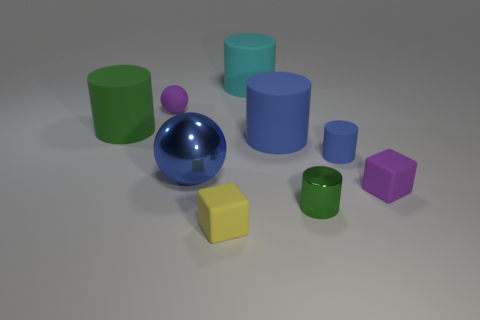There is another object that is the same color as the tiny metallic object; what size is it?
Your answer should be very brief. Large. There is a small cylinder that is the same color as the big ball; what is it made of?
Provide a short and direct response. Rubber. Is the shape of the small purple thing that is to the right of the cyan cylinder the same as the big matte thing that is to the left of the blue sphere?
Provide a succinct answer. No. Are there any other things that are the same size as the yellow matte object?
Your answer should be very brief. Yes. What number of spheres are red shiny objects or yellow matte things?
Ensure brevity in your answer.  0. Does the tiny yellow cube have the same material as the tiny blue thing?
Your answer should be very brief. Yes. How many other things are there of the same color as the matte ball?
Offer a very short reply. 1. There is a large object on the left side of the blue metallic sphere; what is its shape?
Your response must be concise. Cylinder. How many objects are tiny purple blocks or tiny purple matte balls?
Provide a succinct answer. 2. There is a blue metal ball; is it the same size as the purple rubber object left of the small yellow thing?
Your answer should be very brief. No. 